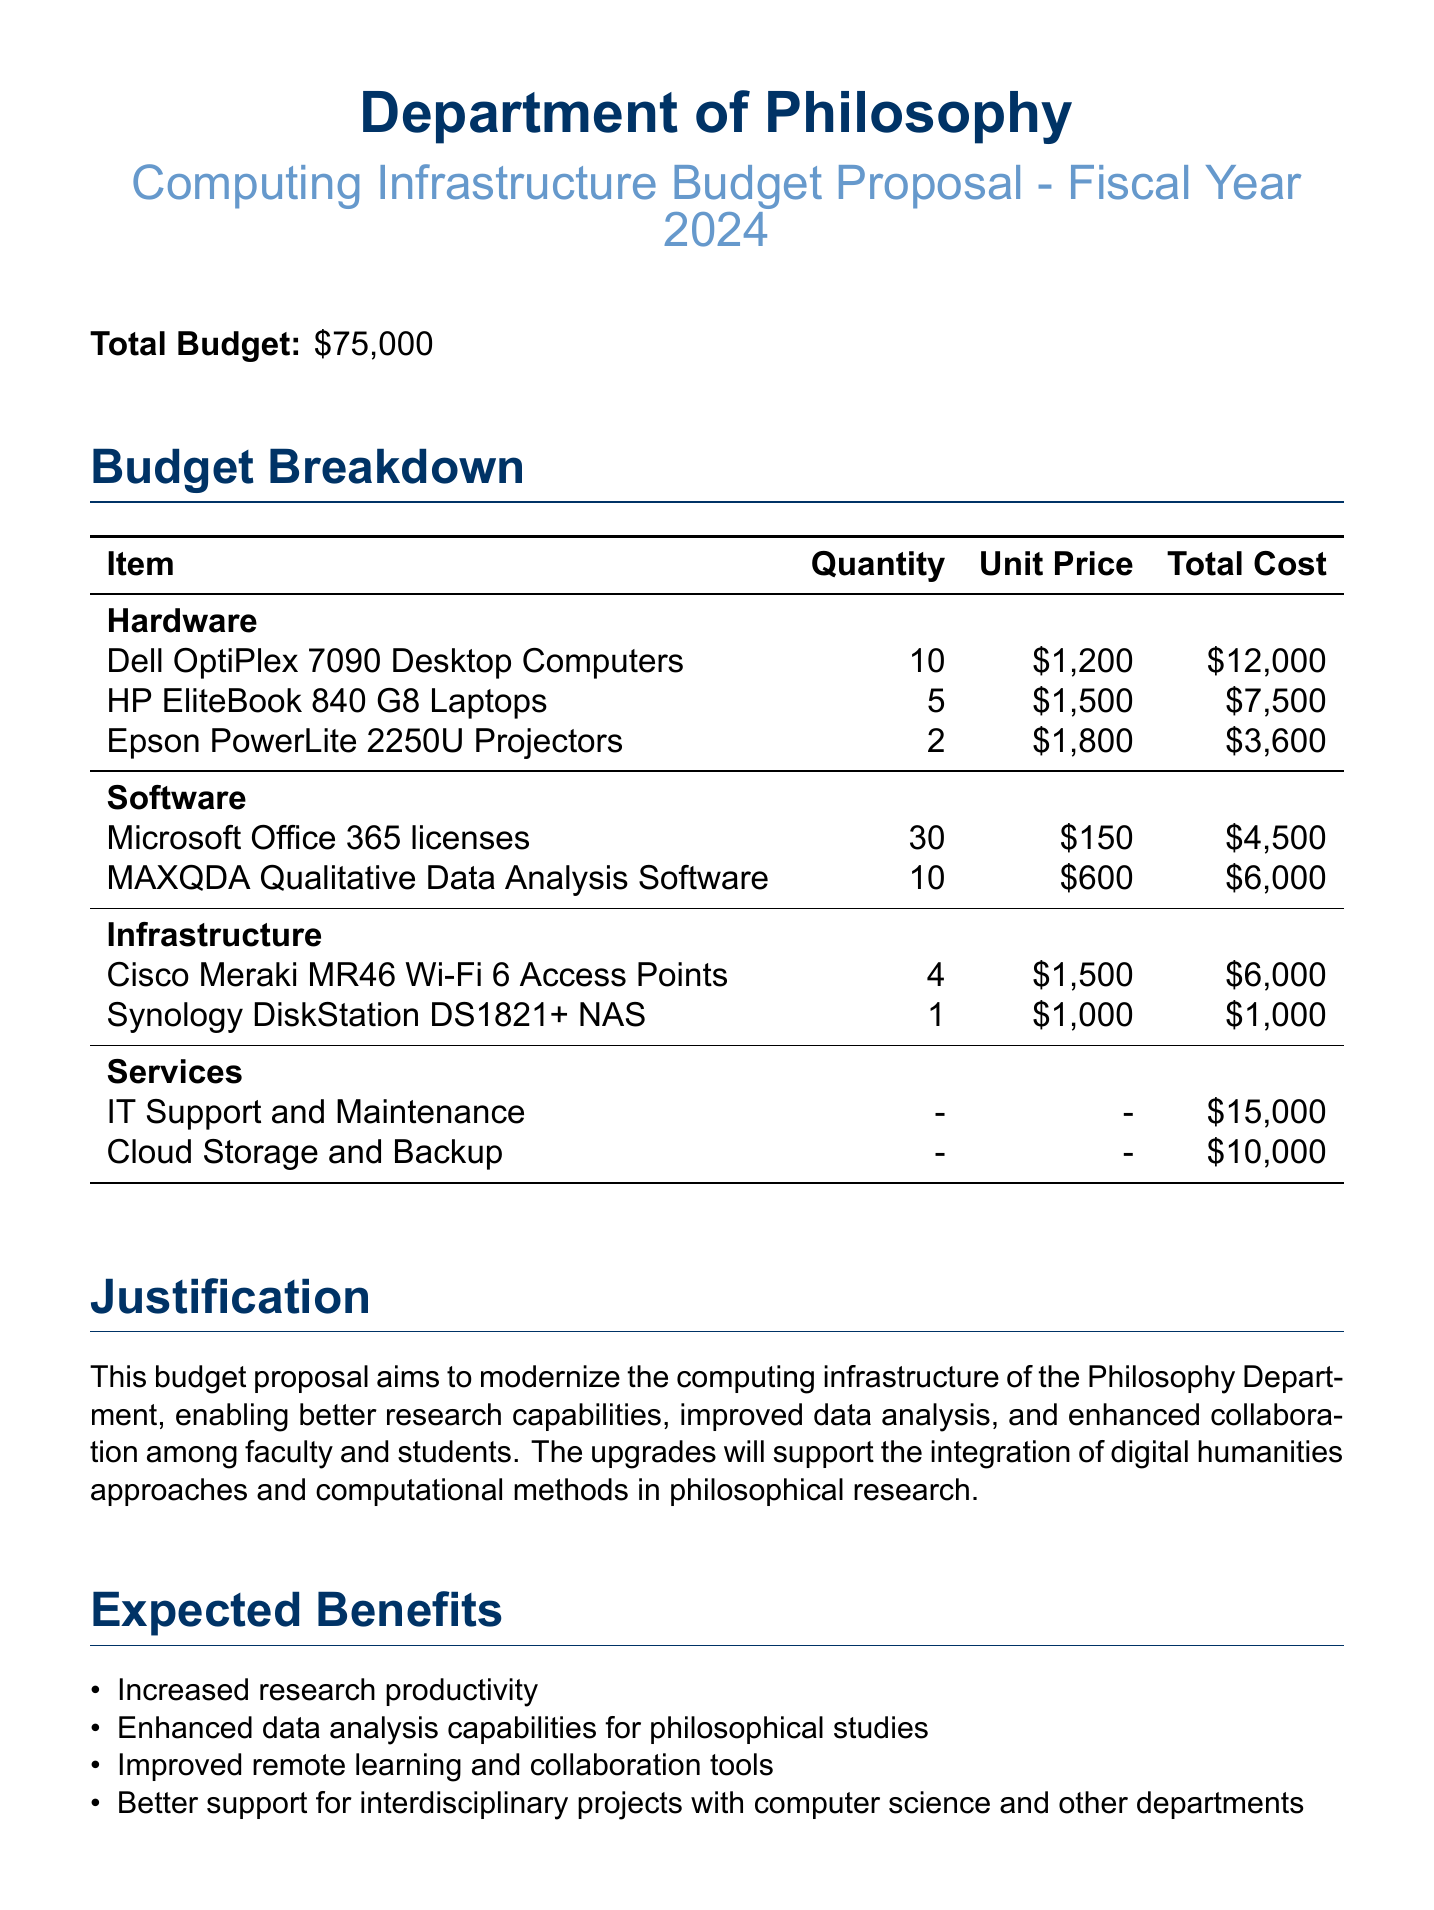What is the total budget? The total budget is clearly stated in the document as $75,000.
Answer: $75,000 How many Dell OptiPlex 7090 Desktop Computers are proposed for purchase? The document lists the quantity of Dell OptiPlex 7090 Desktop Computers as 10.
Answer: 10 What is the total cost for IT Support and Maintenance? The document provides the total cost for IT Support and Maintenance as $15,000.
Answer: $15,000 Which software has a total cost of $6,000? The document indicates that MAXQDA Qualitative Data Analysis Software has a total cost of $6,000.
Answer: MAXQDA Qualitative Data Analysis Software What is one expected benefit mentioned in the proposal? The proposal lists several expected benefits, one of which is increased research productivity.
Answer: Increased research productivity How many items are listed under the Hardware category? The document includes three items under the Hardware category.
Answer: 3 What is the unit price of Cisco Meraki MR46 Wi-Fi 6 Access Points? The unit price for Cisco Meraki MR46 Wi-Fi 6 Access Points is stated as $1,500.
Answer: $1,500 What is the justification for the budget proposal? The document contains a justification explaining that the budget aims to modernize computing infrastructure for better research capabilities.
Answer: Modernize computing infrastructure for better research capabilities 